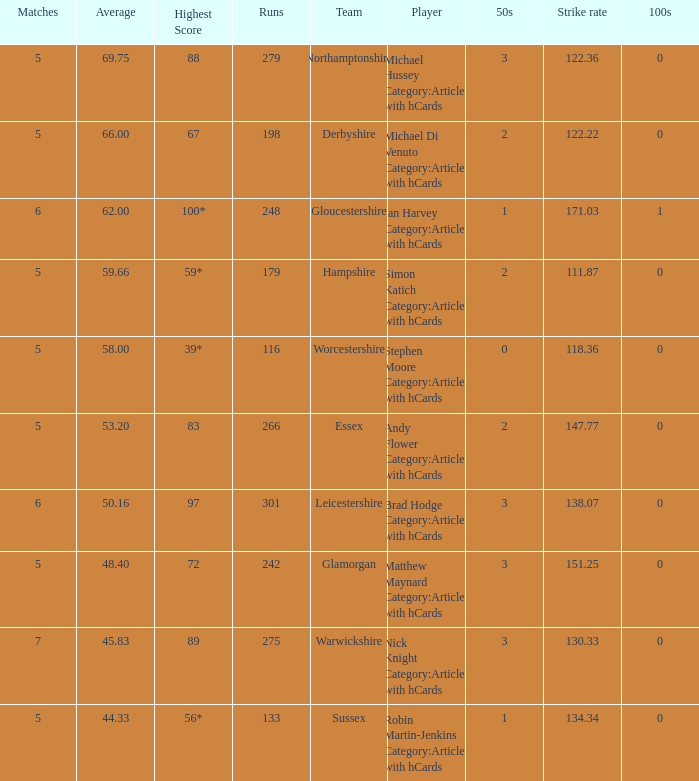What is the smallest amount of matches? 5.0. 